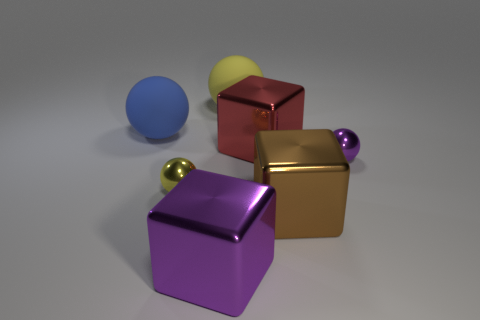Add 2 small yellow metallic spheres. How many objects exist? 9 Subtract all balls. How many objects are left? 3 Subtract all yellow shiny spheres. Subtract all big blue matte spheres. How many objects are left? 5 Add 1 large shiny blocks. How many large shiny blocks are left? 4 Add 6 cyan rubber blocks. How many cyan rubber blocks exist? 6 Subtract 0 yellow cylinders. How many objects are left? 7 